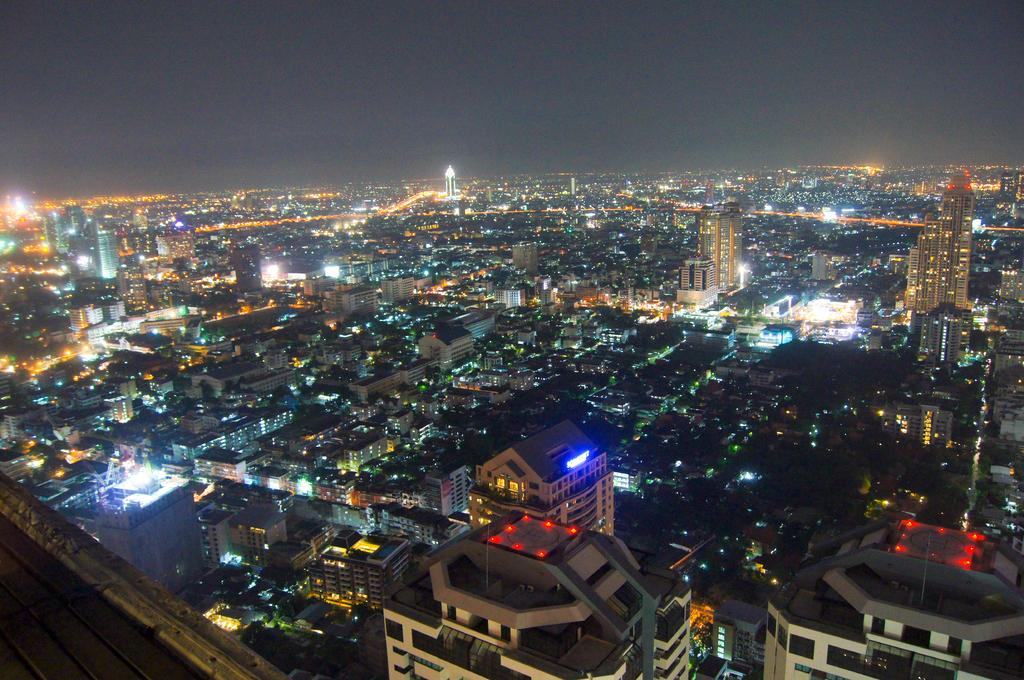What type of structures are present in the image? The image contains buildings. What feature can be observed on the buildings? The buildings have lights. What time of day is depicted in the image? The image is set during night time. What is visible at the top of the image? The sky is visible at the top of the image. What type of vessel is being used to run errands in the image? There is no vessel or running errands depicted in the image; it features buildings with lights during night time. What type of sheet is covering the buildings in the image? There is no sheet covering the buildings in the image; they have lights visible during night time. 